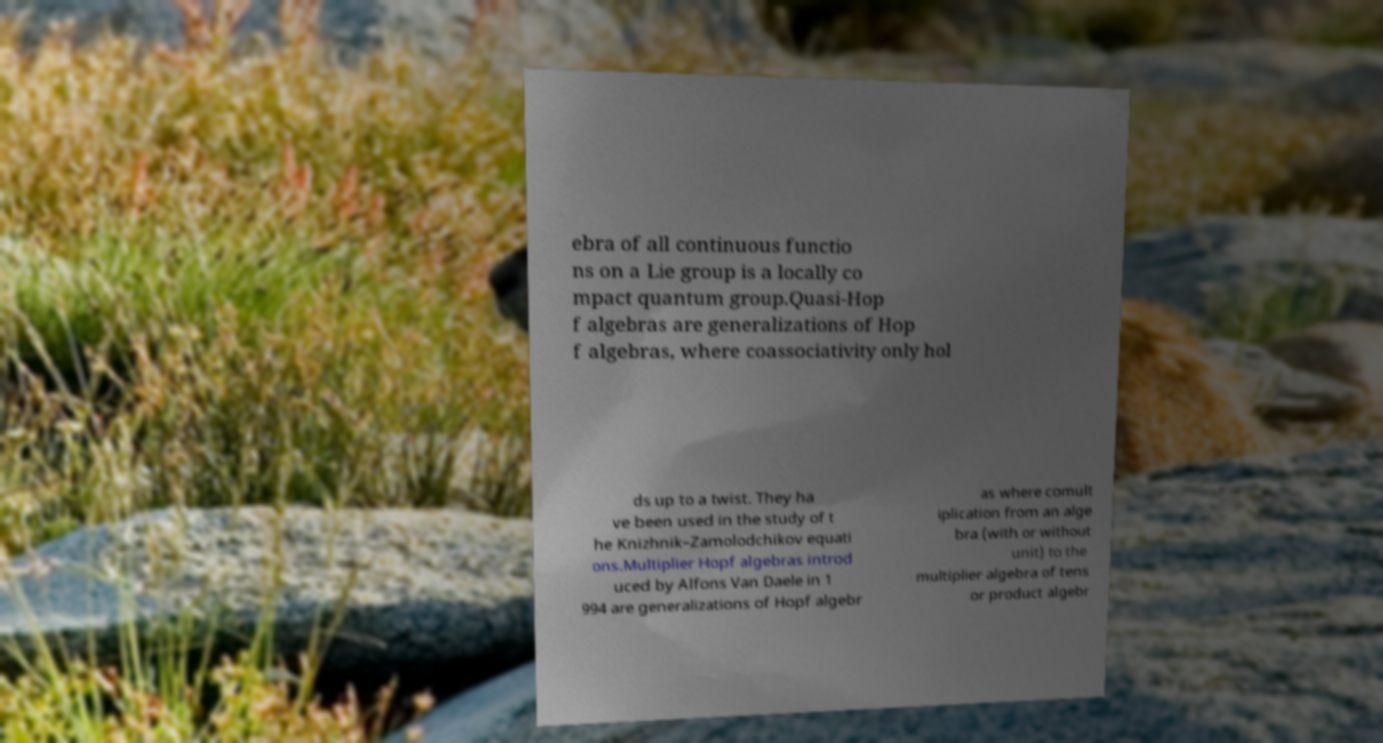Please identify and transcribe the text found in this image. ebra of all continuous functio ns on a Lie group is a locally co mpact quantum group.Quasi-Hop f algebras are generalizations of Hop f algebras, where coassociativity only hol ds up to a twist. They ha ve been used in the study of t he Knizhnik–Zamolodchikov equati ons.Multiplier Hopf algebras introd uced by Alfons Van Daele in 1 994 are generalizations of Hopf algebr as where comult iplication from an alge bra (with or without unit) to the multiplier algebra of tens or product algebr 